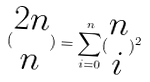Convert formula to latex. <formula><loc_0><loc_0><loc_500><loc_500>( \begin{matrix} 2 n \\ n \end{matrix} ) = \sum _ { i = 0 } ^ { n } ( \begin{matrix} n \\ i \end{matrix} ) ^ { 2 }</formula> 